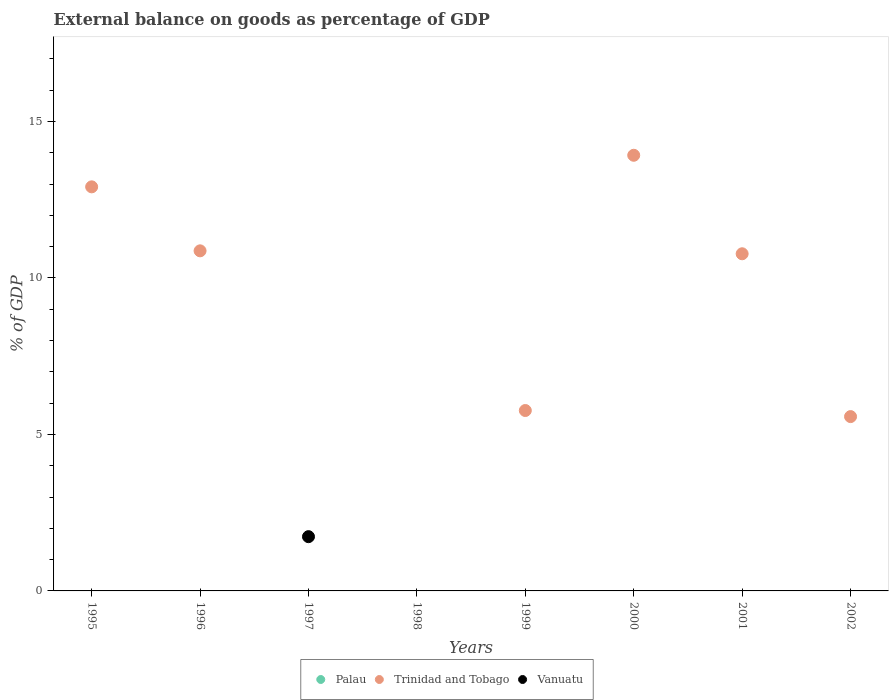Is the number of dotlines equal to the number of legend labels?
Ensure brevity in your answer.  No. What is the external balance on goods as percentage of GDP in Palau in 2002?
Provide a short and direct response. 0. Across all years, what is the maximum external balance on goods as percentage of GDP in Trinidad and Tobago?
Offer a terse response. 13.92. Across all years, what is the minimum external balance on goods as percentage of GDP in Trinidad and Tobago?
Offer a terse response. 0. In which year was the external balance on goods as percentage of GDP in Vanuatu maximum?
Your answer should be very brief. 1997. What is the total external balance on goods as percentage of GDP in Vanuatu in the graph?
Provide a succinct answer. 1.73. What is the difference between the external balance on goods as percentage of GDP in Trinidad and Tobago in 2001 and that in 2002?
Make the answer very short. 5.2. What is the difference between the external balance on goods as percentage of GDP in Trinidad and Tobago in 1998 and the external balance on goods as percentage of GDP in Palau in 1996?
Offer a very short reply. 0. What is the average external balance on goods as percentage of GDP in Palau per year?
Ensure brevity in your answer.  0. In how many years, is the external balance on goods as percentage of GDP in Vanuatu greater than 9 %?
Provide a succinct answer. 0. Is the external balance on goods as percentage of GDP in Trinidad and Tobago in 2001 less than that in 2002?
Ensure brevity in your answer.  No. What is the difference between the highest and the second highest external balance on goods as percentage of GDP in Trinidad and Tobago?
Offer a very short reply. 1.01. What is the difference between the highest and the lowest external balance on goods as percentage of GDP in Vanuatu?
Give a very brief answer. 1.73. Is it the case that in every year, the sum of the external balance on goods as percentage of GDP in Vanuatu and external balance on goods as percentage of GDP in Trinidad and Tobago  is greater than the external balance on goods as percentage of GDP in Palau?
Your answer should be compact. No. Is the external balance on goods as percentage of GDP in Vanuatu strictly greater than the external balance on goods as percentage of GDP in Trinidad and Tobago over the years?
Your answer should be very brief. No. How many years are there in the graph?
Provide a succinct answer. 8. What is the title of the graph?
Provide a short and direct response. External balance on goods as percentage of GDP. Does "Syrian Arab Republic" appear as one of the legend labels in the graph?
Provide a short and direct response. No. What is the label or title of the X-axis?
Provide a succinct answer. Years. What is the label or title of the Y-axis?
Give a very brief answer. % of GDP. What is the % of GDP in Palau in 1995?
Keep it short and to the point. 0. What is the % of GDP in Trinidad and Tobago in 1995?
Your response must be concise. 12.91. What is the % of GDP in Vanuatu in 1995?
Offer a terse response. 0. What is the % of GDP in Trinidad and Tobago in 1996?
Your answer should be compact. 10.87. What is the % of GDP of Vanuatu in 1996?
Your response must be concise. 0. What is the % of GDP in Vanuatu in 1997?
Make the answer very short. 1.73. What is the % of GDP in Trinidad and Tobago in 1999?
Offer a terse response. 5.76. What is the % of GDP of Vanuatu in 1999?
Give a very brief answer. 0. What is the % of GDP of Trinidad and Tobago in 2000?
Make the answer very short. 13.92. What is the % of GDP in Palau in 2001?
Provide a succinct answer. 0. What is the % of GDP of Trinidad and Tobago in 2001?
Your answer should be compact. 10.77. What is the % of GDP of Vanuatu in 2001?
Your answer should be compact. 0. What is the % of GDP of Trinidad and Tobago in 2002?
Your answer should be compact. 5.57. What is the % of GDP of Vanuatu in 2002?
Give a very brief answer. 0. Across all years, what is the maximum % of GDP in Trinidad and Tobago?
Ensure brevity in your answer.  13.92. Across all years, what is the maximum % of GDP of Vanuatu?
Offer a very short reply. 1.73. What is the total % of GDP of Trinidad and Tobago in the graph?
Offer a very short reply. 59.8. What is the total % of GDP in Vanuatu in the graph?
Your answer should be compact. 1.73. What is the difference between the % of GDP of Trinidad and Tobago in 1995 and that in 1996?
Offer a terse response. 2.04. What is the difference between the % of GDP in Trinidad and Tobago in 1995 and that in 1999?
Give a very brief answer. 7.15. What is the difference between the % of GDP in Trinidad and Tobago in 1995 and that in 2000?
Provide a short and direct response. -1.01. What is the difference between the % of GDP of Trinidad and Tobago in 1995 and that in 2001?
Offer a very short reply. 2.14. What is the difference between the % of GDP in Trinidad and Tobago in 1995 and that in 2002?
Provide a short and direct response. 7.34. What is the difference between the % of GDP of Trinidad and Tobago in 1996 and that in 1999?
Your answer should be very brief. 5.1. What is the difference between the % of GDP of Trinidad and Tobago in 1996 and that in 2000?
Keep it short and to the point. -3.05. What is the difference between the % of GDP in Trinidad and Tobago in 1996 and that in 2001?
Ensure brevity in your answer.  0.09. What is the difference between the % of GDP of Trinidad and Tobago in 1996 and that in 2002?
Provide a short and direct response. 5.3. What is the difference between the % of GDP of Trinidad and Tobago in 1999 and that in 2000?
Offer a terse response. -8.15. What is the difference between the % of GDP in Trinidad and Tobago in 1999 and that in 2001?
Ensure brevity in your answer.  -5.01. What is the difference between the % of GDP in Trinidad and Tobago in 1999 and that in 2002?
Keep it short and to the point. 0.19. What is the difference between the % of GDP of Trinidad and Tobago in 2000 and that in 2001?
Offer a very short reply. 3.15. What is the difference between the % of GDP in Trinidad and Tobago in 2000 and that in 2002?
Provide a short and direct response. 8.35. What is the difference between the % of GDP of Trinidad and Tobago in 2001 and that in 2002?
Keep it short and to the point. 5.2. What is the difference between the % of GDP of Trinidad and Tobago in 1995 and the % of GDP of Vanuatu in 1997?
Your response must be concise. 11.18. What is the difference between the % of GDP of Trinidad and Tobago in 1996 and the % of GDP of Vanuatu in 1997?
Your answer should be very brief. 9.13. What is the average % of GDP of Trinidad and Tobago per year?
Ensure brevity in your answer.  7.47. What is the average % of GDP of Vanuatu per year?
Offer a very short reply. 0.22. What is the ratio of the % of GDP of Trinidad and Tobago in 1995 to that in 1996?
Your response must be concise. 1.19. What is the ratio of the % of GDP in Trinidad and Tobago in 1995 to that in 1999?
Your answer should be very brief. 2.24. What is the ratio of the % of GDP of Trinidad and Tobago in 1995 to that in 2000?
Keep it short and to the point. 0.93. What is the ratio of the % of GDP of Trinidad and Tobago in 1995 to that in 2001?
Your response must be concise. 1.2. What is the ratio of the % of GDP of Trinidad and Tobago in 1995 to that in 2002?
Offer a very short reply. 2.32. What is the ratio of the % of GDP of Trinidad and Tobago in 1996 to that in 1999?
Make the answer very short. 1.89. What is the ratio of the % of GDP in Trinidad and Tobago in 1996 to that in 2000?
Offer a very short reply. 0.78. What is the ratio of the % of GDP in Trinidad and Tobago in 1996 to that in 2001?
Your response must be concise. 1.01. What is the ratio of the % of GDP of Trinidad and Tobago in 1996 to that in 2002?
Provide a short and direct response. 1.95. What is the ratio of the % of GDP in Trinidad and Tobago in 1999 to that in 2000?
Make the answer very short. 0.41. What is the ratio of the % of GDP in Trinidad and Tobago in 1999 to that in 2001?
Your response must be concise. 0.54. What is the ratio of the % of GDP in Trinidad and Tobago in 1999 to that in 2002?
Provide a short and direct response. 1.03. What is the ratio of the % of GDP in Trinidad and Tobago in 2000 to that in 2001?
Offer a very short reply. 1.29. What is the ratio of the % of GDP of Trinidad and Tobago in 2000 to that in 2002?
Give a very brief answer. 2.5. What is the ratio of the % of GDP of Trinidad and Tobago in 2001 to that in 2002?
Keep it short and to the point. 1.93. What is the difference between the highest and the second highest % of GDP in Trinidad and Tobago?
Ensure brevity in your answer.  1.01. What is the difference between the highest and the lowest % of GDP of Trinidad and Tobago?
Provide a succinct answer. 13.92. What is the difference between the highest and the lowest % of GDP in Vanuatu?
Make the answer very short. 1.73. 